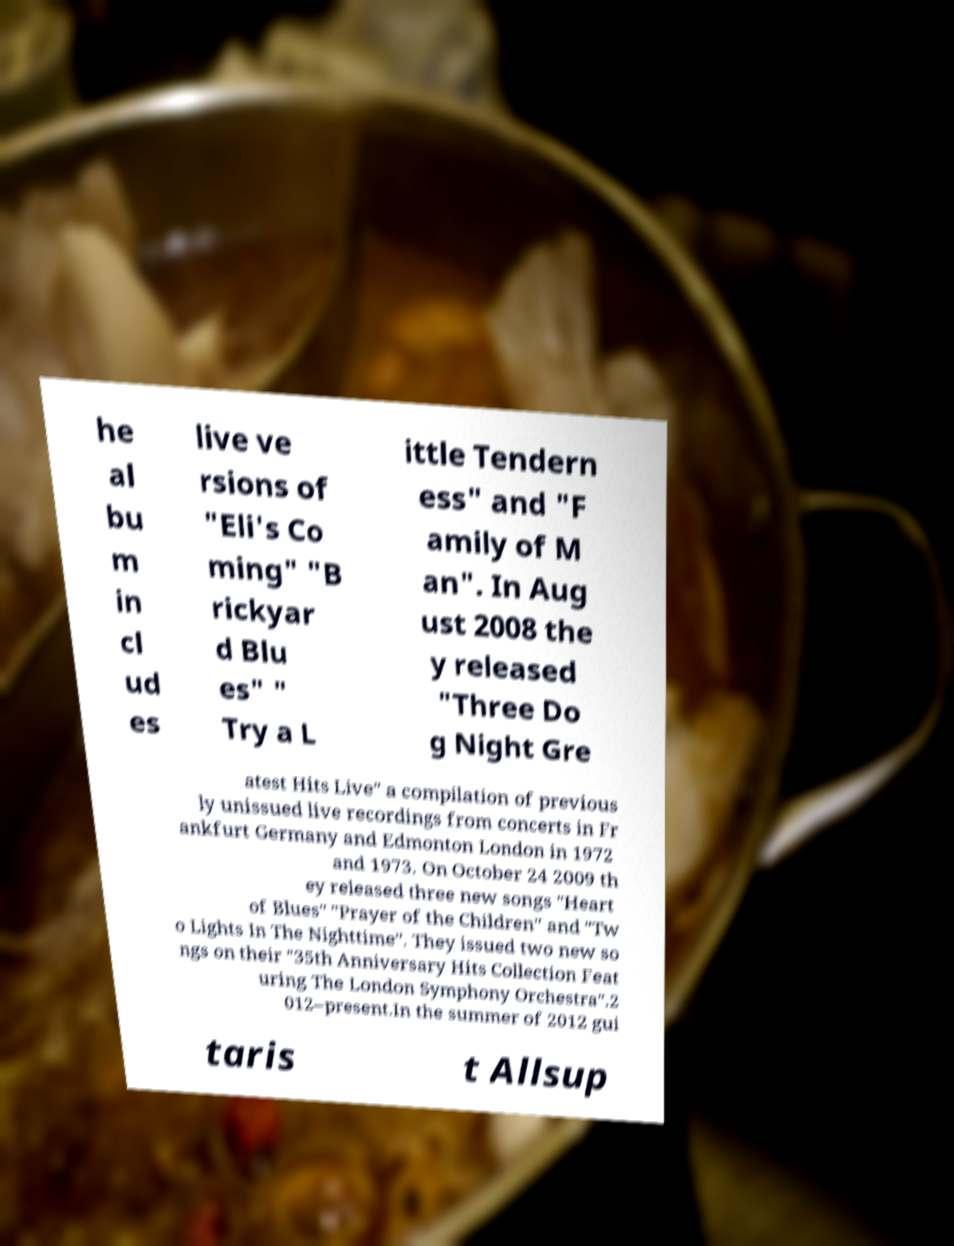Can you read and provide the text displayed in the image?This photo seems to have some interesting text. Can you extract and type it out for me? he al bu m in cl ud es live ve rsions of "Eli's Co ming" "B rickyar d Blu es" " Try a L ittle Tendern ess" and "F amily of M an". In Aug ust 2008 the y released "Three Do g Night Gre atest Hits Live" a compilation of previous ly unissued live recordings from concerts in Fr ankfurt Germany and Edmonton London in 1972 and 1973. On October 24 2009 th ey released three new songs "Heart of Blues" "Prayer of the Children" and "Tw o Lights In The Nighttime". They issued two new so ngs on their "35th Anniversary Hits Collection Feat uring The London Symphony Orchestra".2 012–present.In the summer of 2012 gui taris t Allsup 